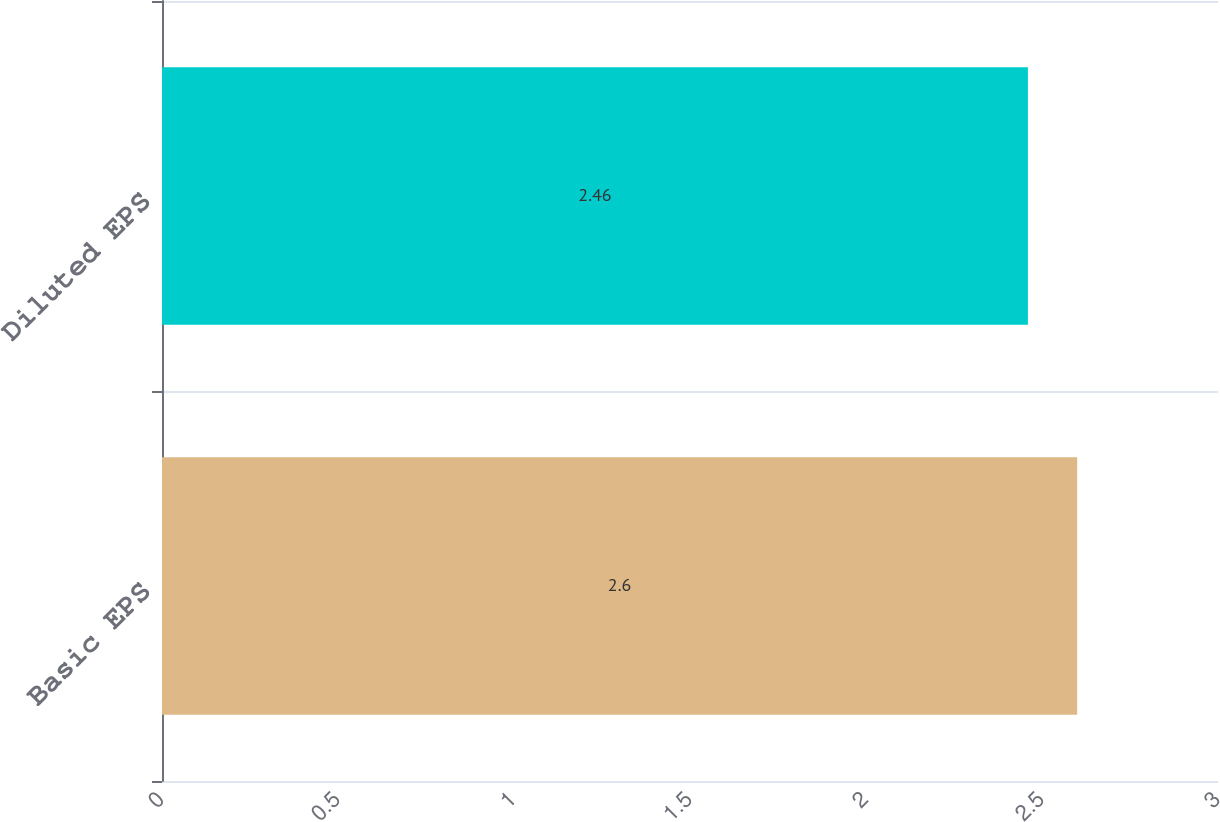Convert chart. <chart><loc_0><loc_0><loc_500><loc_500><bar_chart><fcel>Basic EPS<fcel>Diluted EPS<nl><fcel>2.6<fcel>2.46<nl></chart> 